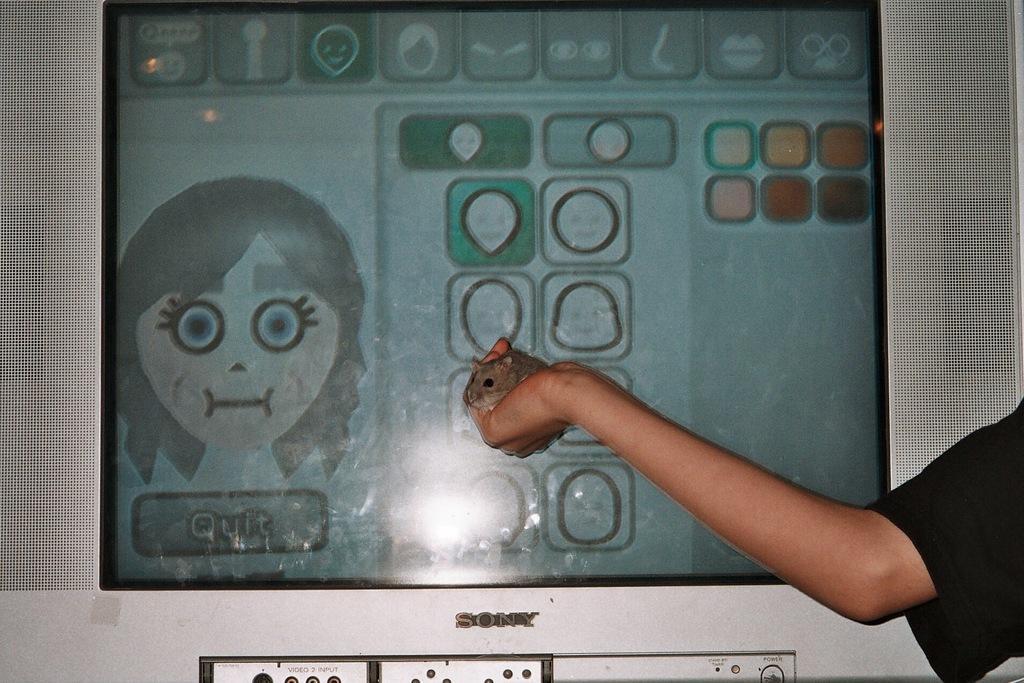Could you give a brief overview of what you see in this image? On the right side of the image we can see a person's hand holding a mouse. In the background there is a television. 